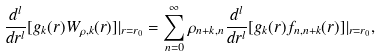<formula> <loc_0><loc_0><loc_500><loc_500>\frac { d ^ { l } } { d r ^ { l } } [ g _ { k } ( r ) W _ { \rho , k } ( r ) ] | _ { r = r _ { 0 } } = \sum _ { n = 0 } ^ { \infty } \rho _ { n + k , n } \frac { d ^ { l } } { d r ^ { l } } [ g _ { k } ( r ) f _ { n , n + k } ( r ) ] | _ { r = r _ { 0 } } ,</formula> 